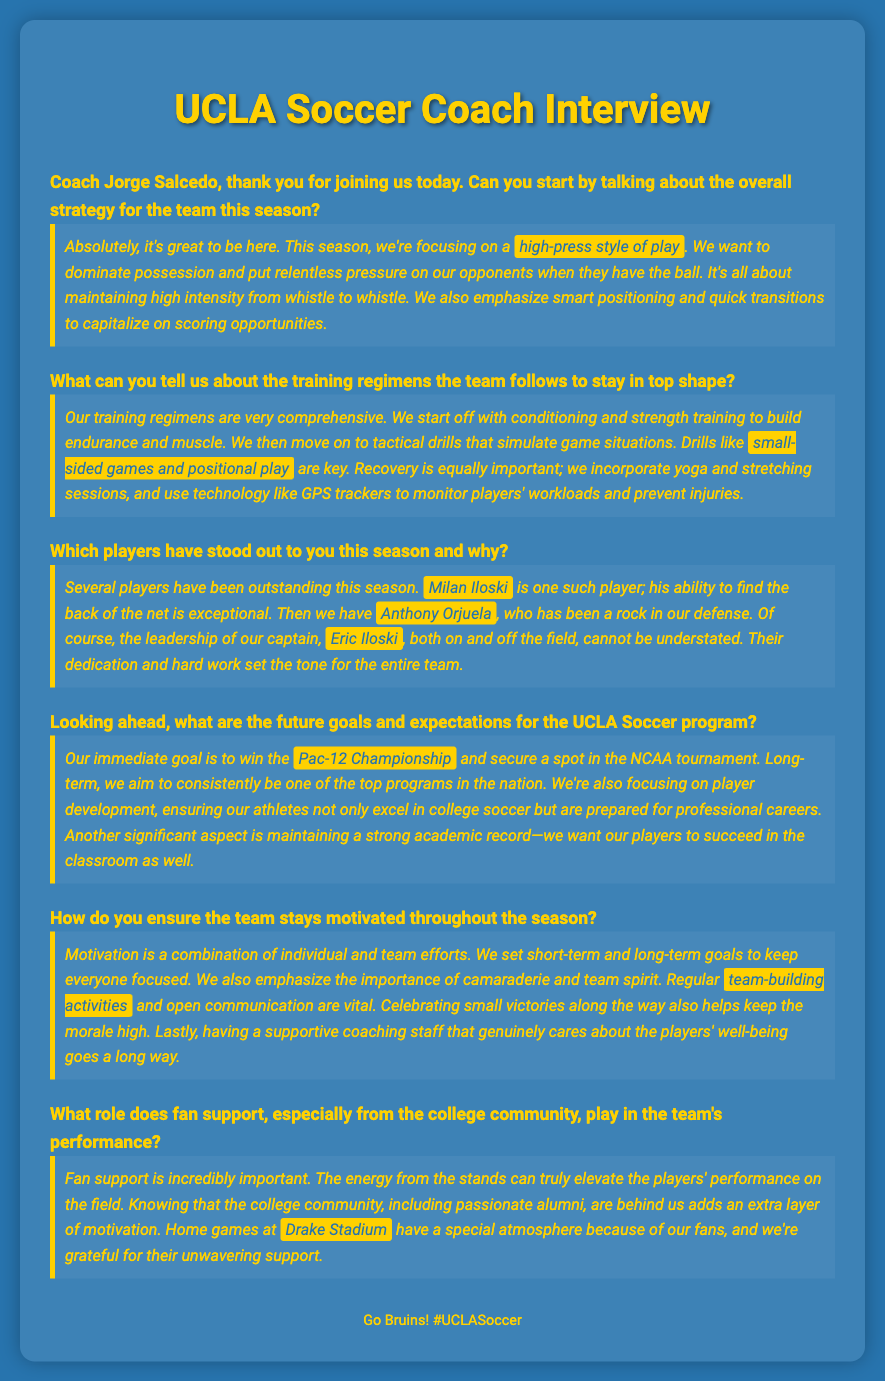What is the overall strategy for the team this season? Coach Salcedo stated that the team is focusing on a high-press style of play to dominate possession and maintain high intensity.
Answer: high-press style of play What kind of training drills are emphasized? The coach mentioned that tactical drills such as small-sided games and positional play are key components of their training regimen.
Answer: small-sided games and positional play Who is noted for their goal-scoring ability this season? Milan Iloski was highlighted by the coach for his exceptional ability to find the back of the net.
Answer: Milan Iloski What is the immediate goal for the UCLA Soccer program this season? The immediate goal mentioned by the coach is to win the Pac-12 Championship and secure a spot in the NCAA tournament.
Answer: Pac-12 Championship What aspect is emphasized alongside sports performance? The coach emphasized the importance of maintaining a strong academic record for the players.
Answer: strong academic record Where do home games take place? The coach highlighted that home games are held at Drake Stadium, which adds to the special atmosphere due to fan support.
Answer: Drake Stadium What activities help keep the team motivated? Coach Salcedo mentioned that regular team-building activities play a vital role in keeping the team motivated.
Answer: team-building activities 